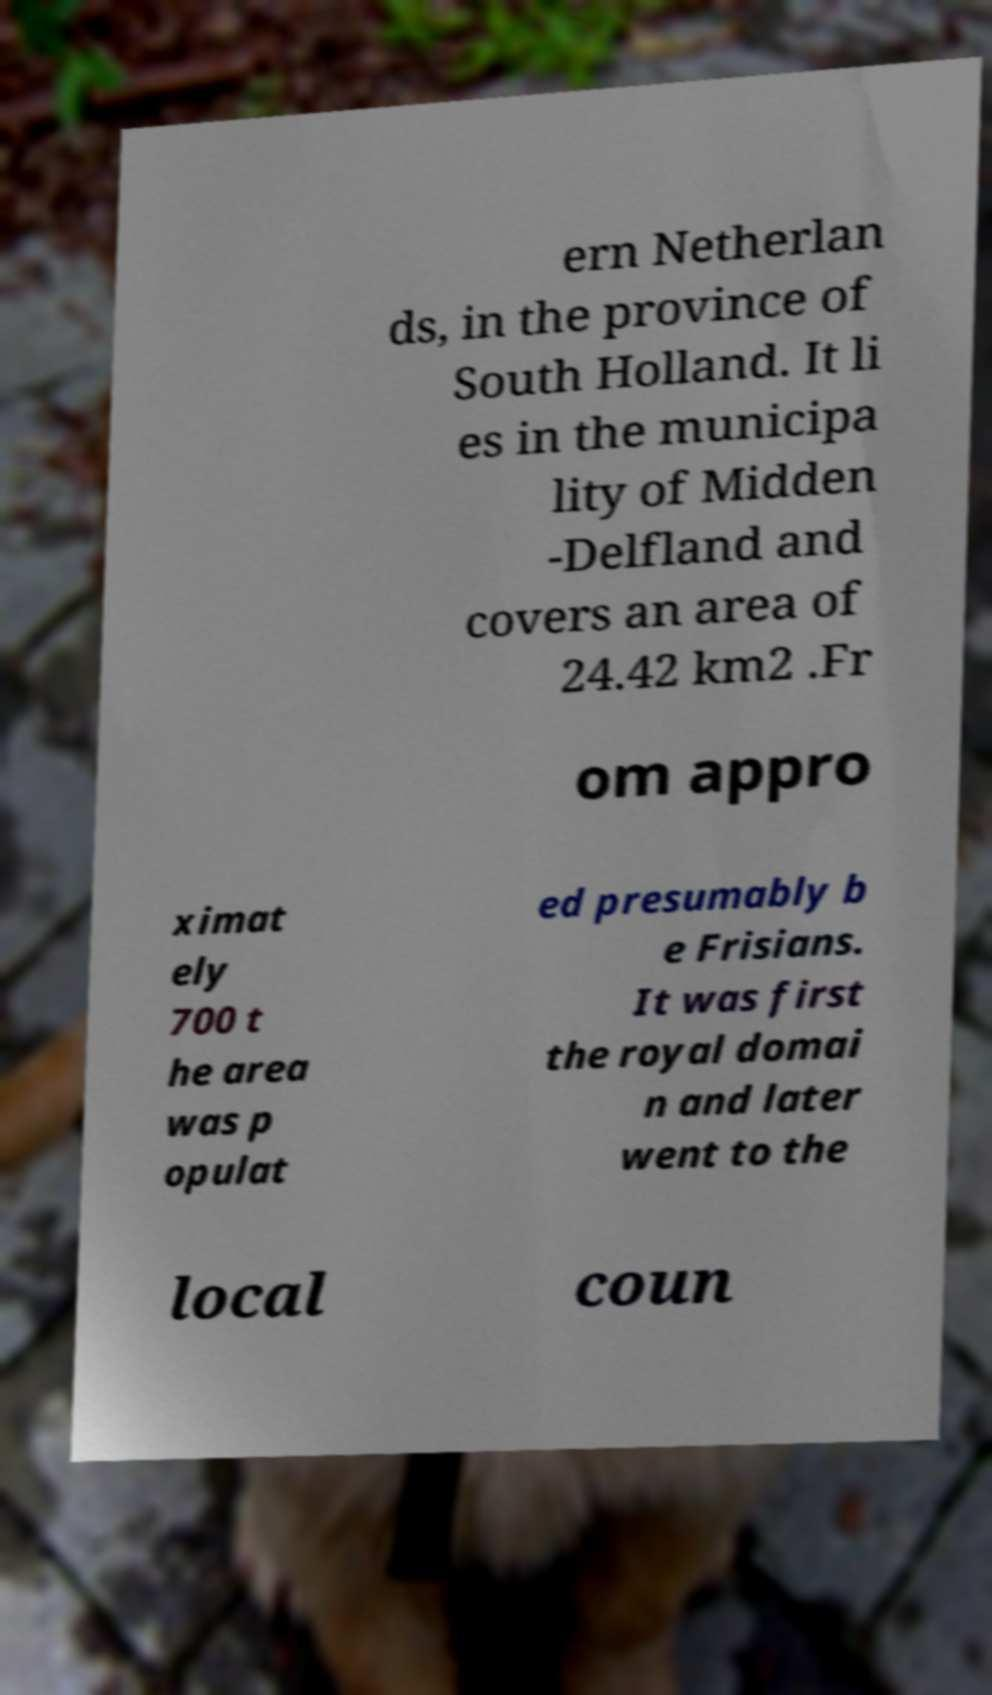Could you extract and type out the text from this image? ern Netherlan ds, in the province of South Holland. It li es in the municipa lity of Midden -Delfland and covers an area of 24.42 km2 .Fr om appro ximat ely 700 t he area was p opulat ed presumably b e Frisians. It was first the royal domai n and later went to the local coun 